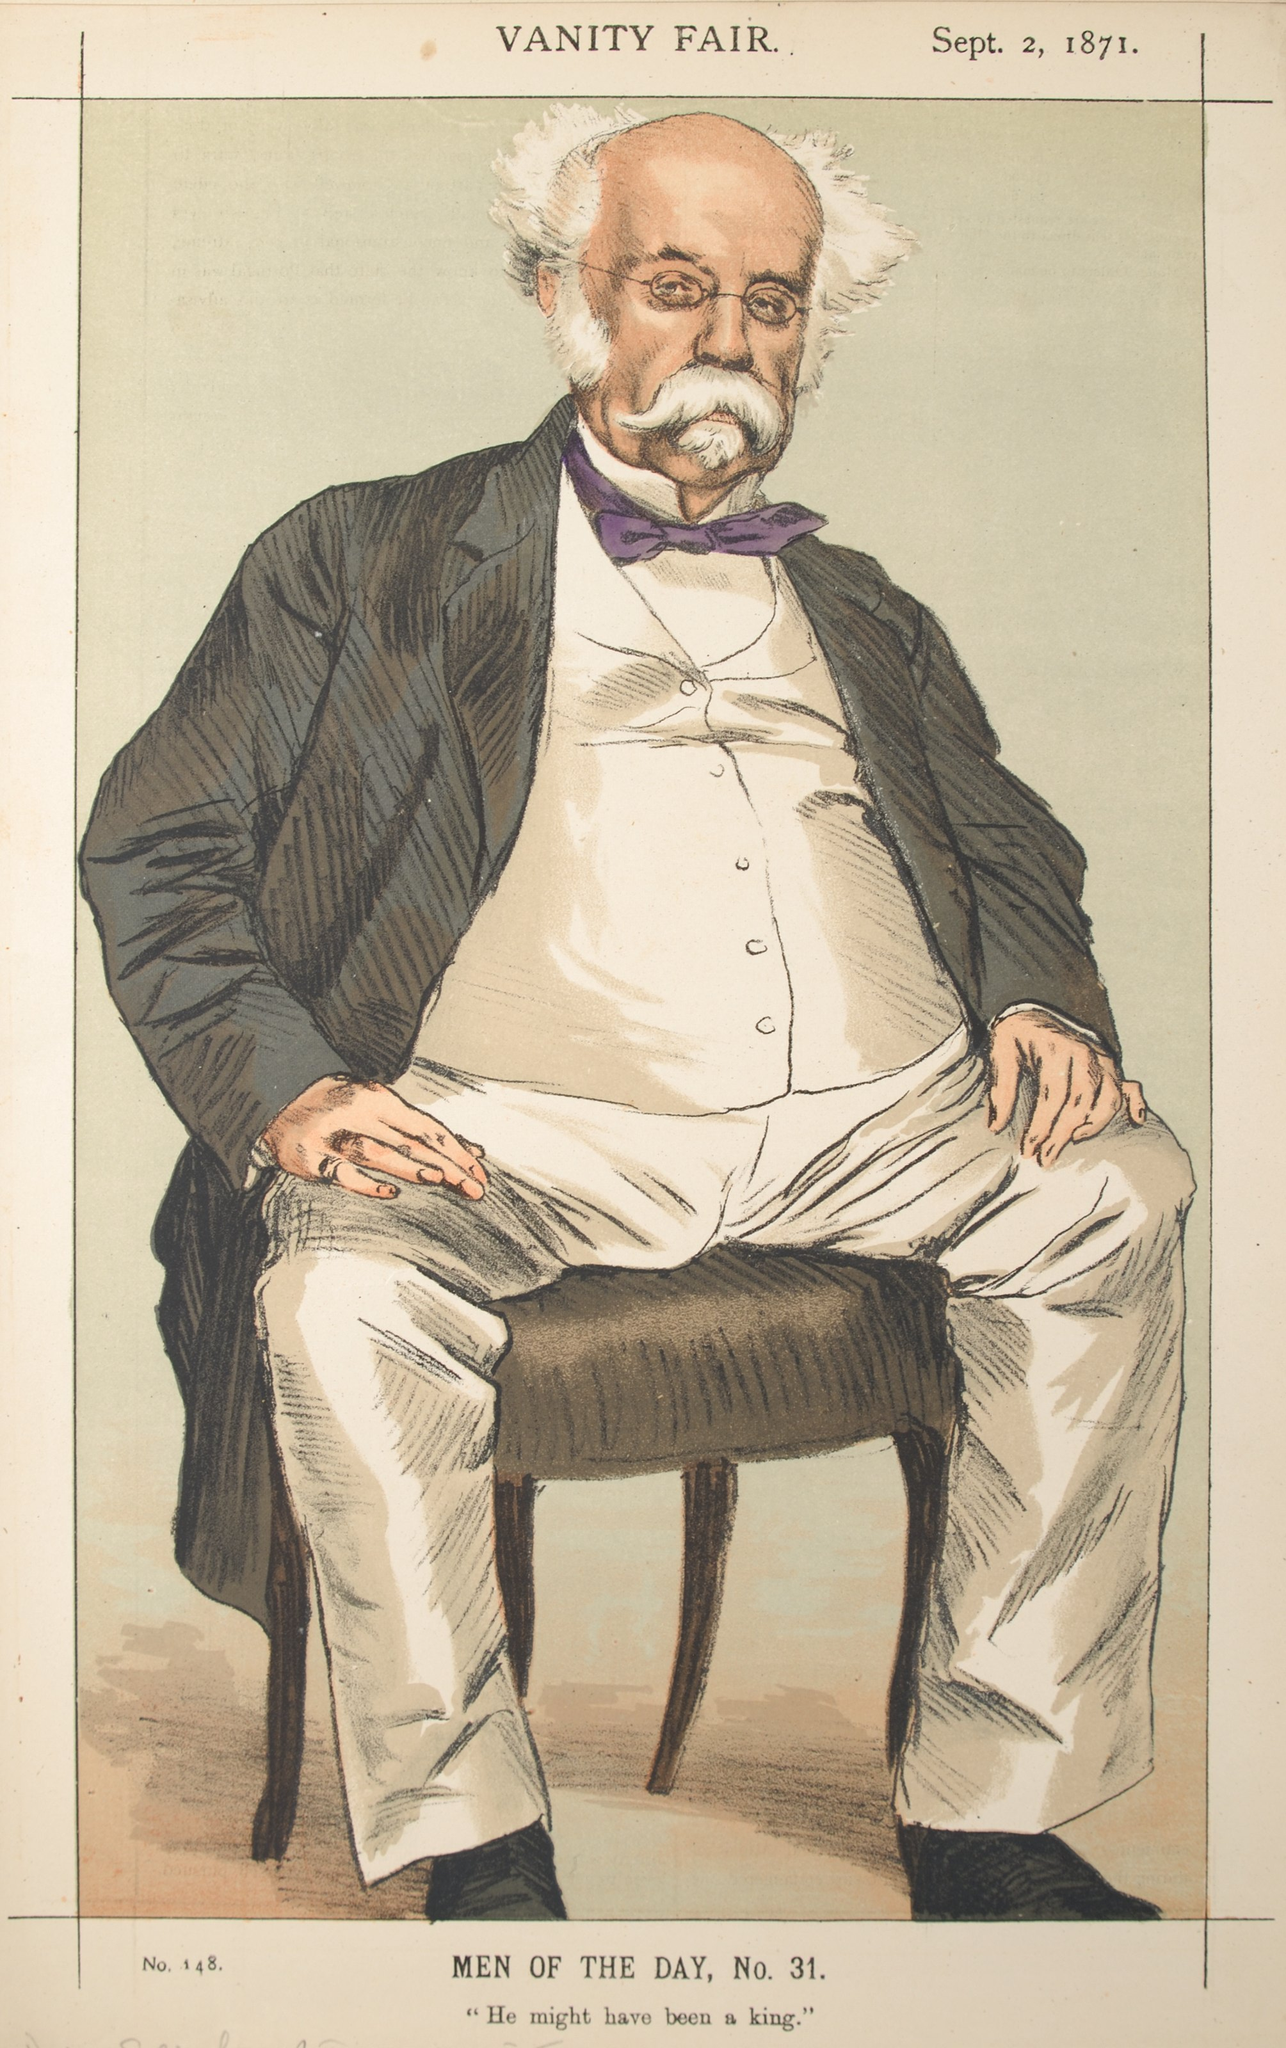Who is the man depicted in this Vanity Fair caricature? The man depicted is likely a notable figure from the 19th century, often politicians, artists, or other public personalities were subjects of Vanity Fair caricatures. The exact identity isn't provided in the image, but the stylized elements suggest a humorous take on someone influential during that period. Can you elaborate on the style and purpose of Vanity Fair caricatures? Vanity Fair caricatures were a distinctive feature of the magazine in the late 19th and early 20th centuries. These illustrations were often satirical, aiming to humorously exaggerate the physical and personality traits of the depicted individuals. Through bold lines and exaggerated features, the artworks provided social and political commentary, poking fun at the quirks and behaviors of well-known figures. The primary purpose was to entertain readers and offer subtle critiques wrapped in humor, embodying the spirit of satire. 